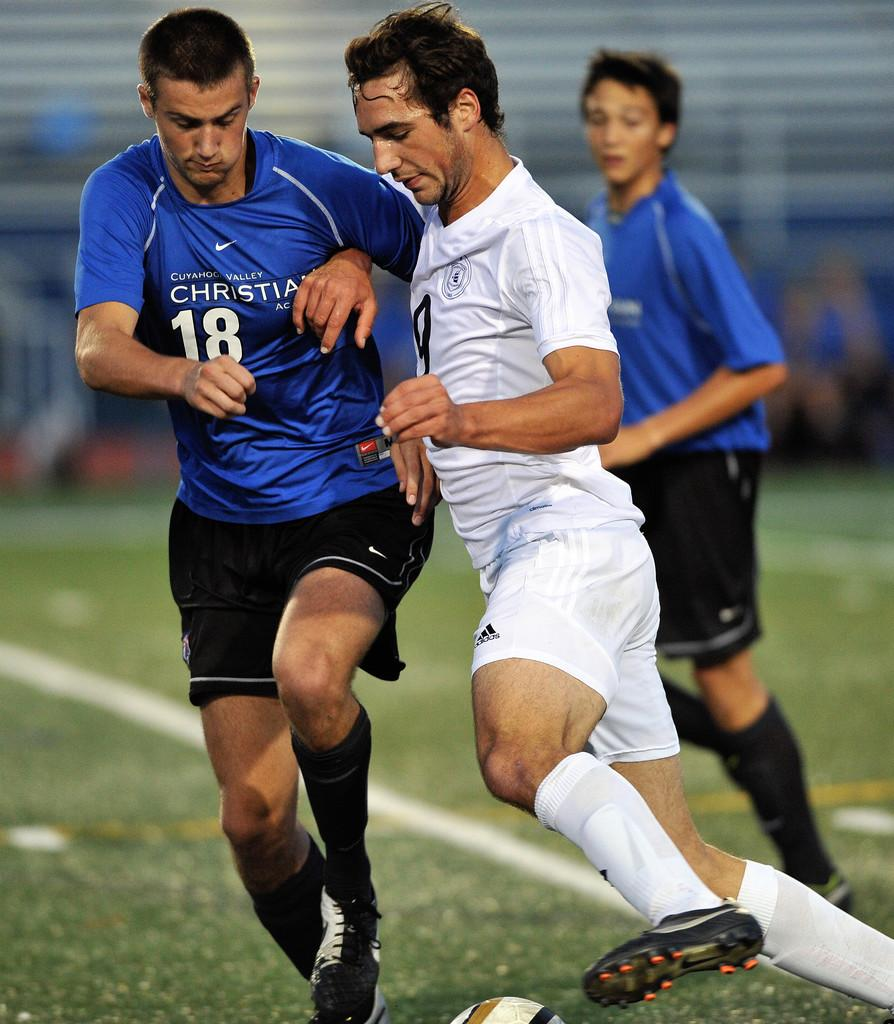<image>
Give a short and clear explanation of the subsequent image. Cuyahoga Valley has a soccer team with blue uniforms. 